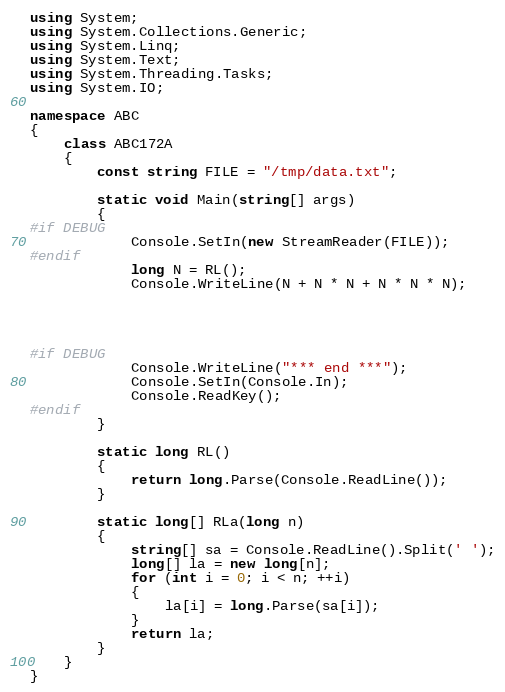<code> <loc_0><loc_0><loc_500><loc_500><_C#_>using System;
using System.Collections.Generic;
using System.Linq;
using System.Text;
using System.Threading.Tasks;
using System.IO;

namespace ABC
{
    class ABC172A
    {
        const string FILE = "/tmp/data.txt";

        static void Main(string[] args)
        {
#if DEBUG
            Console.SetIn(new StreamReader(FILE));
#endif
            long N = RL();
            Console.WriteLine(N + N * N + N * N * N);




#if DEBUG
            Console.WriteLine("*** end ***");
            Console.SetIn(Console.In);
            Console.ReadKey();
#endif
        }

        static long RL()
        {
            return long.Parse(Console.ReadLine());
        }

        static long[] RLa(long n)
        {
            string[] sa = Console.ReadLine().Split(' ');
            long[] la = new long[n];
            for (int i = 0; i < n; ++i)
            {
                la[i] = long.Parse(sa[i]);
            }
            return la;
        }
    }
}
</code> 